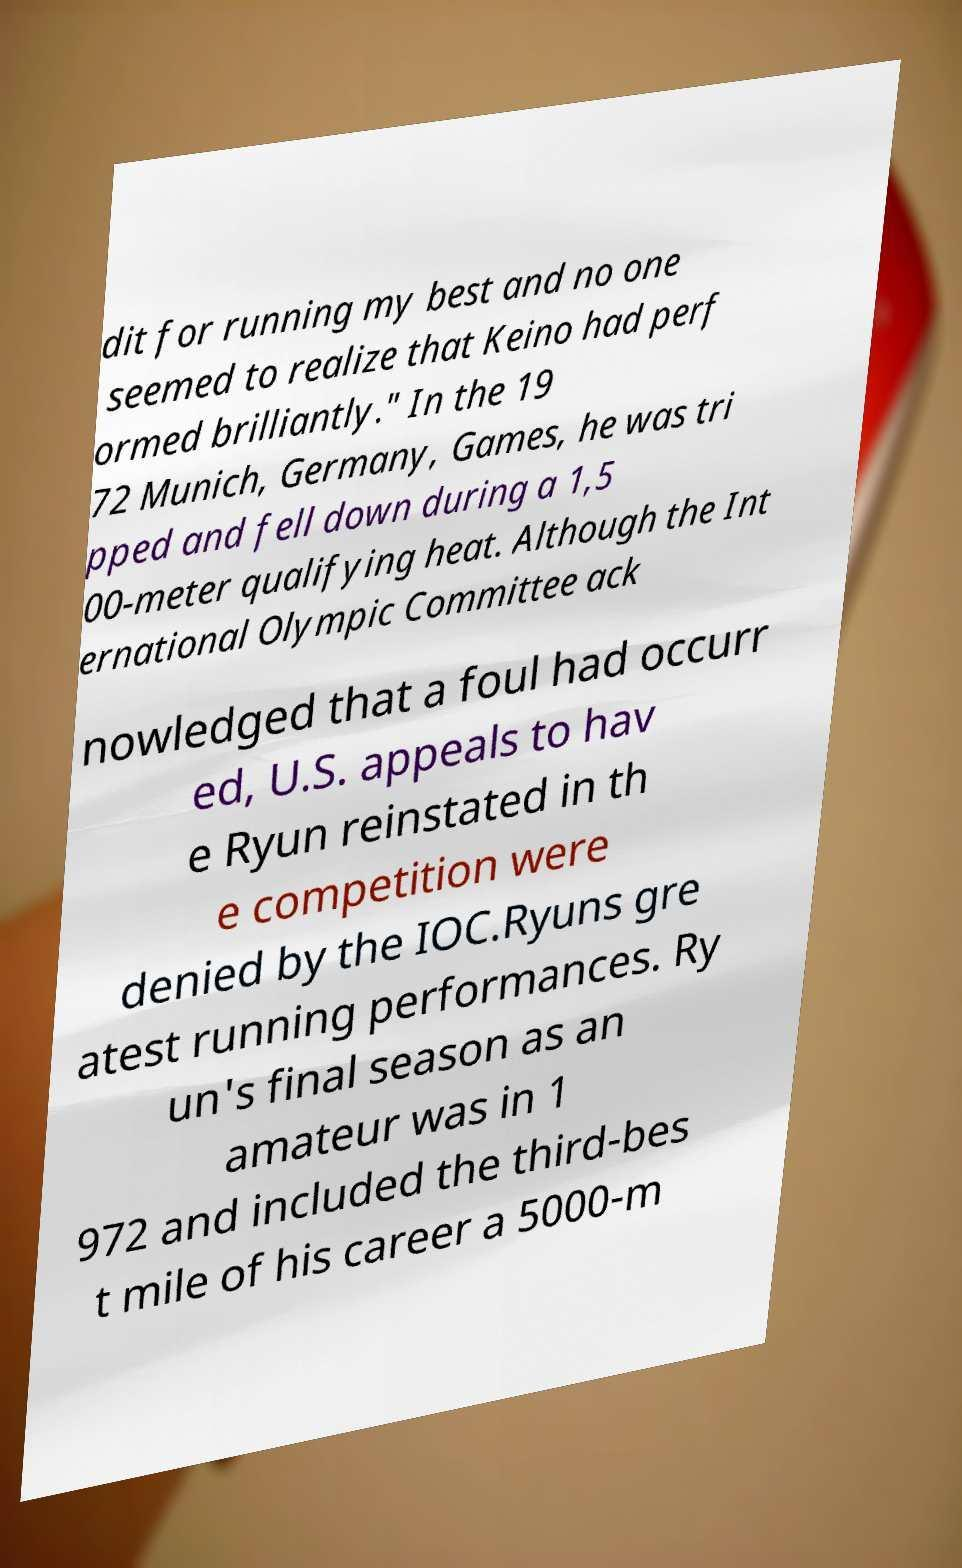What messages or text are displayed in this image? I need them in a readable, typed format. dit for running my best and no one seemed to realize that Keino had perf ormed brilliantly." In the 19 72 Munich, Germany, Games, he was tri pped and fell down during a 1,5 00-meter qualifying heat. Although the Int ernational Olympic Committee ack nowledged that a foul had occurr ed, U.S. appeals to hav e Ryun reinstated in th e competition were denied by the IOC.Ryuns gre atest running performances. Ry un's final season as an amateur was in 1 972 and included the third-bes t mile of his career a 5000-m 